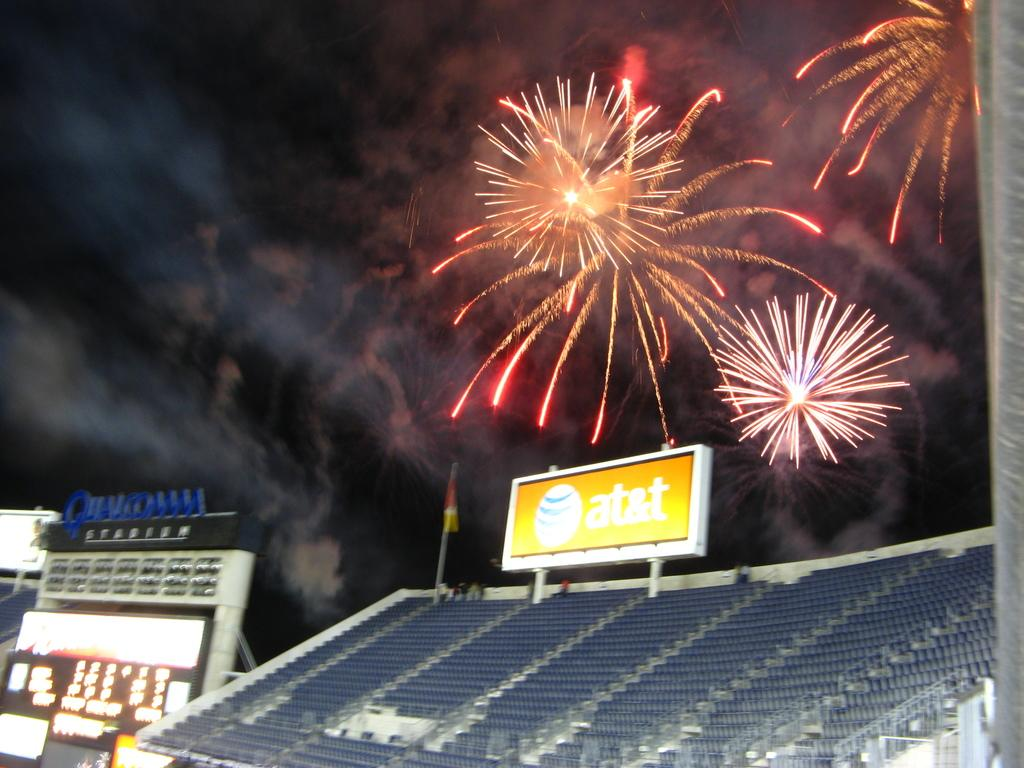Provide a one-sentence caption for the provided image. Fireworks explode in the sky above Qualcomm Stadium. 